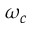Convert formula to latex. <formula><loc_0><loc_0><loc_500><loc_500>\omega _ { c }</formula> 